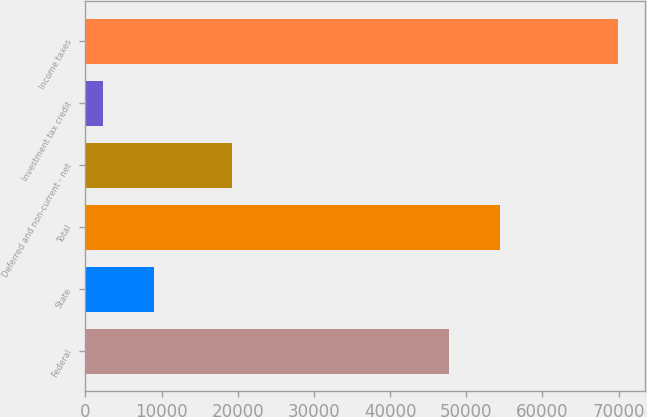Convert chart. <chart><loc_0><loc_0><loc_500><loc_500><bar_chart><fcel>Federal<fcel>State<fcel>Total<fcel>Deferred and non-current - net<fcel>Investment tax credit<fcel>Income taxes<nl><fcel>47674<fcel>9032.7<fcel>54444.7<fcel>19243<fcel>2262<fcel>69969<nl></chart> 